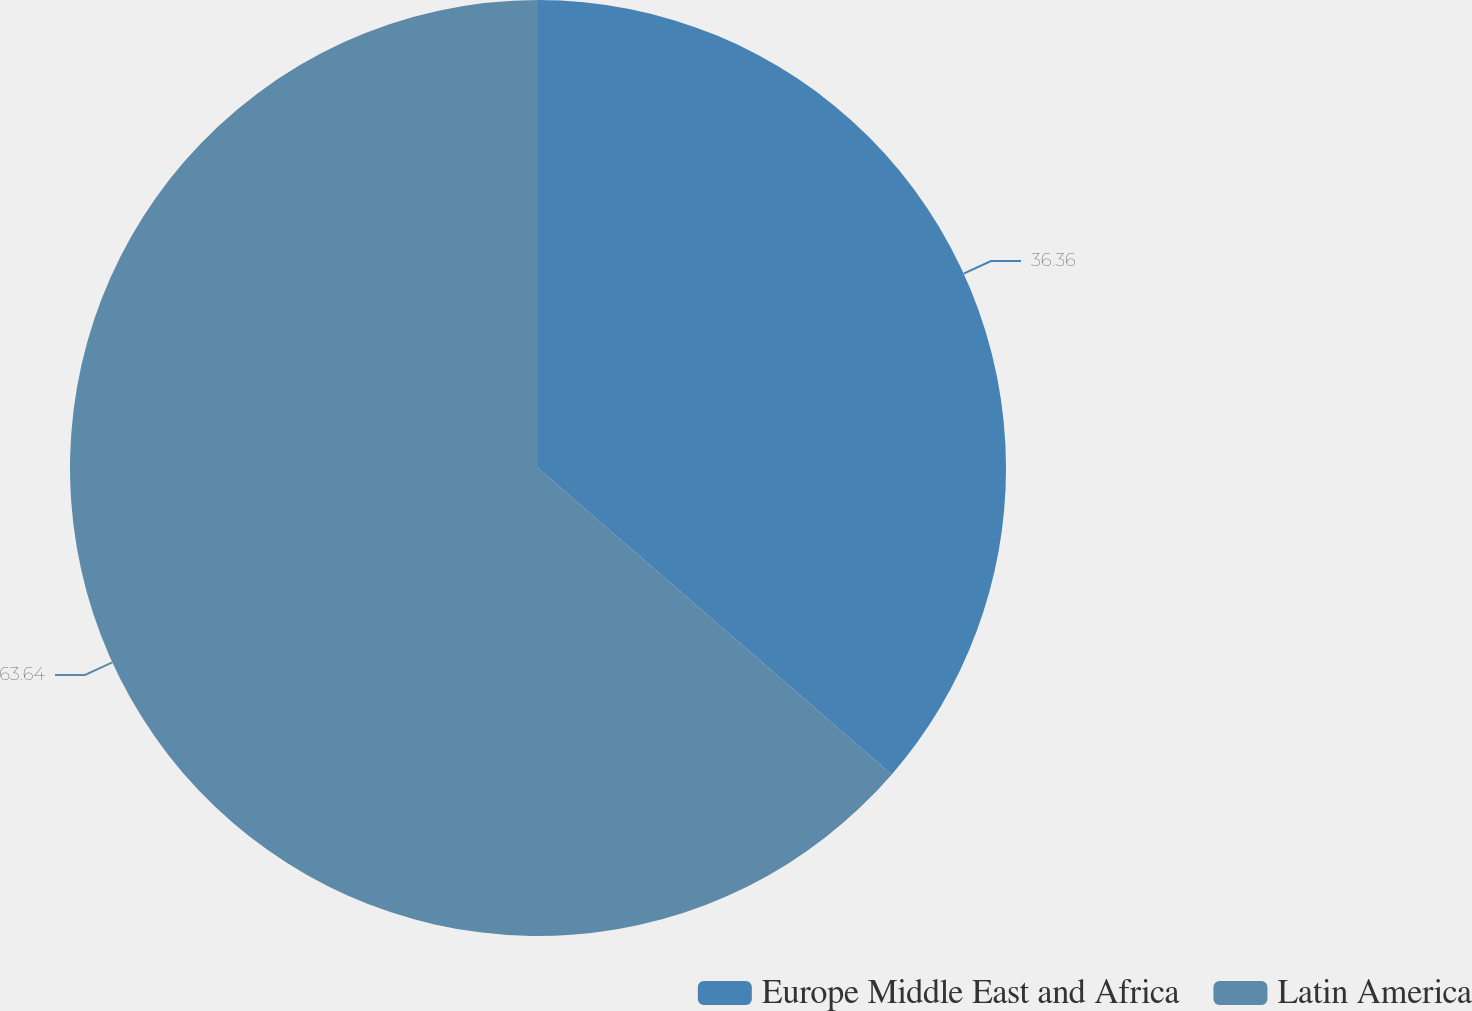<chart> <loc_0><loc_0><loc_500><loc_500><pie_chart><fcel>Europe Middle East and Africa<fcel>Latin America<nl><fcel>36.36%<fcel>63.64%<nl></chart> 